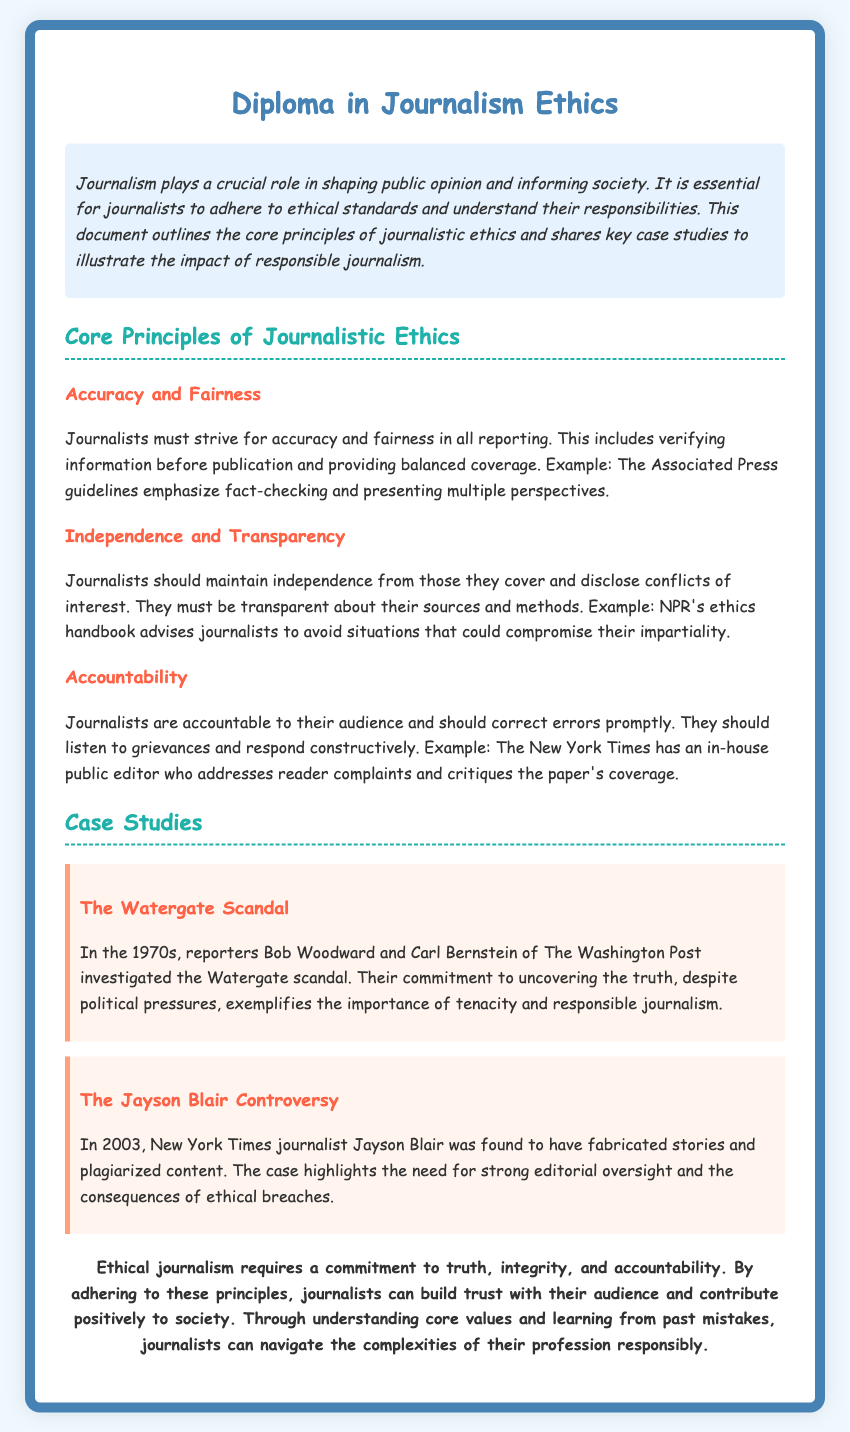What is the title of the document? The title of the document is revealed in the header section of the rendered HTML, which states, "Diploma in Journalism Ethics."
Answer: Diploma in Journalism Ethics What is one of the core principles of journalistic ethics? The document lists several principles; one mentioned is "Accuracy and Fairness."
Answer: Accuracy and Fairness Which organization is mentioned regarding fact-checking guidelines? The text references the Associated Press in the context of journalism guidelines on accuracy.
Answer: Associated Press Who investigated the Watergate scandal? The document states that reporters Bob Woodward and Carl Bernstein of The Washington Post were responsible for the investigation.
Answer: Bob Woodward and Carl Bernstein What year did the Jayson Blair controversy take place? According to the document, this controversy occurred in 2003.
Answer: 2003 What is the main responsibility of journalists mentioned in the conclusion? The conclusion emphasizes the commitment to "truth, integrity, and accountability."
Answer: truth, integrity, and accountability What does NPR's ethics handbook advise regarding impartiality? The document states that NPR's ethics handbook advises journalists to avoid situations that could compromise their impartiality.
Answer: Avoid situations that could compromise impartiality How many case studies are included in the document? The document includes two case studies about the Watergate scandal and the Jayson Blair controversy.
Answer: Two What color is the background of the document? The background color is specified as "#f0f8ff" in the style section of the HTML.
Answer: #f0f8ff 